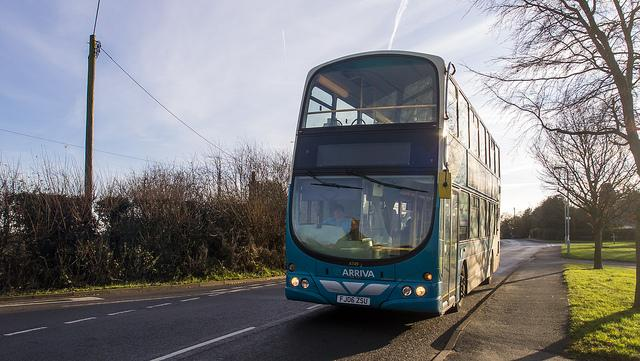How is this bus different from traditional US buses? Please explain your reasoning. double-decker. This bus has two levels visible through the front windshield. most buses operating in the us have one level so this would be distinct because of the double deck. 